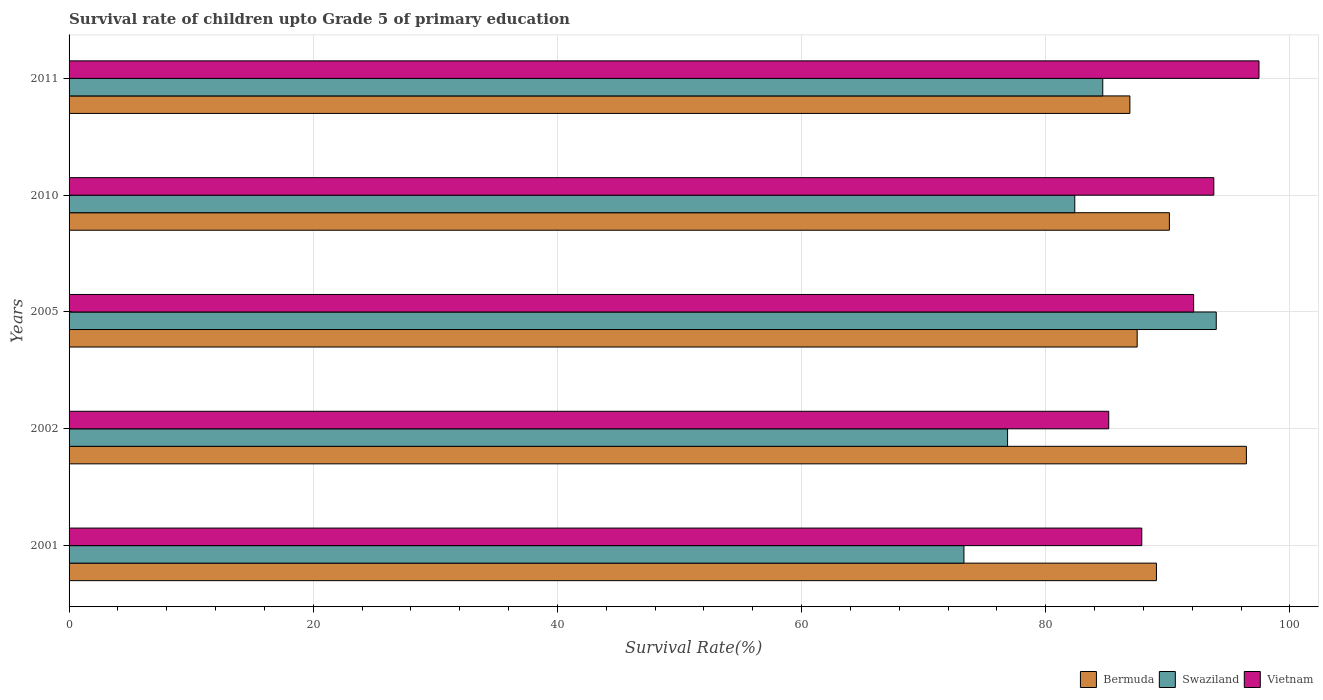How many different coloured bars are there?
Offer a very short reply. 3. How many groups of bars are there?
Your response must be concise. 5. Are the number of bars per tick equal to the number of legend labels?
Give a very brief answer. Yes. How many bars are there on the 5th tick from the bottom?
Your answer should be very brief. 3. What is the survival rate of children in Vietnam in 2001?
Your response must be concise. 87.87. Across all years, what is the maximum survival rate of children in Vietnam?
Ensure brevity in your answer.  97.47. Across all years, what is the minimum survival rate of children in Swaziland?
Your answer should be compact. 73.3. What is the total survival rate of children in Vietnam in the graph?
Keep it short and to the point. 456.41. What is the difference between the survival rate of children in Swaziland in 2005 and that in 2010?
Offer a very short reply. 11.59. What is the difference between the survival rate of children in Swaziland in 2011 and the survival rate of children in Bermuda in 2001?
Provide a short and direct response. -4.4. What is the average survival rate of children in Swaziland per year?
Offer a terse response. 82.24. In the year 2011, what is the difference between the survival rate of children in Bermuda and survival rate of children in Vietnam?
Your answer should be compact. -10.58. In how many years, is the survival rate of children in Bermuda greater than 52 %?
Your answer should be very brief. 5. What is the ratio of the survival rate of children in Bermuda in 2002 to that in 2011?
Offer a terse response. 1.11. Is the survival rate of children in Vietnam in 2001 less than that in 2011?
Your answer should be compact. Yes. Is the difference between the survival rate of children in Bermuda in 2002 and 2005 greater than the difference between the survival rate of children in Vietnam in 2002 and 2005?
Your answer should be compact. Yes. What is the difference between the highest and the second highest survival rate of children in Vietnam?
Provide a succinct answer. 3.7. What is the difference between the highest and the lowest survival rate of children in Swaziland?
Your answer should be compact. 20.67. What does the 3rd bar from the top in 2002 represents?
Your response must be concise. Bermuda. What does the 2nd bar from the bottom in 2005 represents?
Ensure brevity in your answer.  Swaziland. Is it the case that in every year, the sum of the survival rate of children in Vietnam and survival rate of children in Bermuda is greater than the survival rate of children in Swaziland?
Offer a very short reply. Yes. How many bars are there?
Make the answer very short. 15. How many years are there in the graph?
Your response must be concise. 5. What is the difference between two consecutive major ticks on the X-axis?
Give a very brief answer. 20. Are the values on the major ticks of X-axis written in scientific E-notation?
Your answer should be compact. No. What is the title of the graph?
Ensure brevity in your answer.  Survival rate of children upto Grade 5 of primary education. Does "Belarus" appear as one of the legend labels in the graph?
Offer a very short reply. No. What is the label or title of the X-axis?
Offer a terse response. Survival Rate(%). What is the Survival Rate(%) of Bermuda in 2001?
Offer a terse response. 89.07. What is the Survival Rate(%) of Swaziland in 2001?
Offer a terse response. 73.3. What is the Survival Rate(%) in Vietnam in 2001?
Offer a terse response. 87.87. What is the Survival Rate(%) of Bermuda in 2002?
Your answer should be compact. 96.44. What is the Survival Rate(%) in Swaziland in 2002?
Provide a succinct answer. 76.88. What is the Survival Rate(%) of Vietnam in 2002?
Your response must be concise. 85.17. What is the Survival Rate(%) of Bermuda in 2005?
Offer a very short reply. 87.5. What is the Survival Rate(%) of Swaziland in 2005?
Keep it short and to the point. 93.97. What is the Survival Rate(%) of Vietnam in 2005?
Provide a short and direct response. 92.12. What is the Survival Rate(%) in Bermuda in 2010?
Ensure brevity in your answer.  90.13. What is the Survival Rate(%) in Swaziland in 2010?
Offer a very short reply. 82.38. What is the Survival Rate(%) of Vietnam in 2010?
Your answer should be very brief. 93.78. What is the Survival Rate(%) in Bermuda in 2011?
Provide a short and direct response. 86.9. What is the Survival Rate(%) in Swaziland in 2011?
Make the answer very short. 84.68. What is the Survival Rate(%) of Vietnam in 2011?
Your response must be concise. 97.47. Across all years, what is the maximum Survival Rate(%) in Bermuda?
Keep it short and to the point. 96.44. Across all years, what is the maximum Survival Rate(%) in Swaziland?
Offer a very short reply. 93.97. Across all years, what is the maximum Survival Rate(%) of Vietnam?
Offer a terse response. 97.47. Across all years, what is the minimum Survival Rate(%) of Bermuda?
Offer a very short reply. 86.9. Across all years, what is the minimum Survival Rate(%) of Swaziland?
Keep it short and to the point. 73.3. Across all years, what is the minimum Survival Rate(%) of Vietnam?
Provide a short and direct response. 85.17. What is the total Survival Rate(%) in Bermuda in the graph?
Your response must be concise. 450.05. What is the total Survival Rate(%) of Swaziland in the graph?
Your response must be concise. 411.22. What is the total Survival Rate(%) of Vietnam in the graph?
Your answer should be compact. 456.41. What is the difference between the Survival Rate(%) of Bermuda in 2001 and that in 2002?
Offer a terse response. -7.37. What is the difference between the Survival Rate(%) in Swaziland in 2001 and that in 2002?
Offer a very short reply. -3.57. What is the difference between the Survival Rate(%) in Vietnam in 2001 and that in 2002?
Offer a very short reply. 2.71. What is the difference between the Survival Rate(%) of Bermuda in 2001 and that in 2005?
Offer a very short reply. 1.58. What is the difference between the Survival Rate(%) in Swaziland in 2001 and that in 2005?
Your answer should be compact. -20.67. What is the difference between the Survival Rate(%) of Vietnam in 2001 and that in 2005?
Provide a succinct answer. -4.25. What is the difference between the Survival Rate(%) in Bermuda in 2001 and that in 2010?
Your answer should be very brief. -1.06. What is the difference between the Survival Rate(%) of Swaziland in 2001 and that in 2010?
Offer a terse response. -9.08. What is the difference between the Survival Rate(%) in Vietnam in 2001 and that in 2010?
Offer a very short reply. -5.9. What is the difference between the Survival Rate(%) of Bermuda in 2001 and that in 2011?
Your answer should be compact. 2.18. What is the difference between the Survival Rate(%) in Swaziland in 2001 and that in 2011?
Your answer should be very brief. -11.37. What is the difference between the Survival Rate(%) of Vietnam in 2001 and that in 2011?
Ensure brevity in your answer.  -9.6. What is the difference between the Survival Rate(%) of Bermuda in 2002 and that in 2005?
Your response must be concise. 8.95. What is the difference between the Survival Rate(%) in Swaziland in 2002 and that in 2005?
Make the answer very short. -17.09. What is the difference between the Survival Rate(%) in Vietnam in 2002 and that in 2005?
Provide a succinct answer. -6.96. What is the difference between the Survival Rate(%) in Bermuda in 2002 and that in 2010?
Ensure brevity in your answer.  6.31. What is the difference between the Survival Rate(%) in Swaziland in 2002 and that in 2010?
Keep it short and to the point. -5.51. What is the difference between the Survival Rate(%) in Vietnam in 2002 and that in 2010?
Offer a very short reply. -8.61. What is the difference between the Survival Rate(%) of Bermuda in 2002 and that in 2011?
Keep it short and to the point. 9.54. What is the difference between the Survival Rate(%) of Swaziland in 2002 and that in 2011?
Your answer should be compact. -7.8. What is the difference between the Survival Rate(%) in Vietnam in 2002 and that in 2011?
Provide a succinct answer. -12.31. What is the difference between the Survival Rate(%) of Bermuda in 2005 and that in 2010?
Ensure brevity in your answer.  -2.64. What is the difference between the Survival Rate(%) of Swaziland in 2005 and that in 2010?
Provide a succinct answer. 11.59. What is the difference between the Survival Rate(%) of Vietnam in 2005 and that in 2010?
Your answer should be compact. -1.65. What is the difference between the Survival Rate(%) of Bermuda in 2005 and that in 2011?
Your response must be concise. 0.6. What is the difference between the Survival Rate(%) in Swaziland in 2005 and that in 2011?
Give a very brief answer. 9.3. What is the difference between the Survival Rate(%) in Vietnam in 2005 and that in 2011?
Offer a very short reply. -5.35. What is the difference between the Survival Rate(%) of Bermuda in 2010 and that in 2011?
Your answer should be very brief. 3.24. What is the difference between the Survival Rate(%) of Swaziland in 2010 and that in 2011?
Offer a very short reply. -2.29. What is the difference between the Survival Rate(%) in Vietnam in 2010 and that in 2011?
Keep it short and to the point. -3.7. What is the difference between the Survival Rate(%) of Bermuda in 2001 and the Survival Rate(%) of Swaziland in 2002?
Offer a very short reply. 12.2. What is the difference between the Survival Rate(%) of Bermuda in 2001 and the Survival Rate(%) of Vietnam in 2002?
Offer a very short reply. 3.91. What is the difference between the Survival Rate(%) of Swaziland in 2001 and the Survival Rate(%) of Vietnam in 2002?
Keep it short and to the point. -11.86. What is the difference between the Survival Rate(%) of Bermuda in 2001 and the Survival Rate(%) of Swaziland in 2005?
Make the answer very short. -4.9. What is the difference between the Survival Rate(%) in Bermuda in 2001 and the Survival Rate(%) in Vietnam in 2005?
Make the answer very short. -3.05. What is the difference between the Survival Rate(%) of Swaziland in 2001 and the Survival Rate(%) of Vietnam in 2005?
Provide a succinct answer. -18.82. What is the difference between the Survival Rate(%) of Bermuda in 2001 and the Survival Rate(%) of Swaziland in 2010?
Make the answer very short. 6.69. What is the difference between the Survival Rate(%) of Bermuda in 2001 and the Survival Rate(%) of Vietnam in 2010?
Give a very brief answer. -4.7. What is the difference between the Survival Rate(%) in Swaziland in 2001 and the Survival Rate(%) in Vietnam in 2010?
Make the answer very short. -20.47. What is the difference between the Survival Rate(%) of Bermuda in 2001 and the Survival Rate(%) of Swaziland in 2011?
Ensure brevity in your answer.  4.4. What is the difference between the Survival Rate(%) of Bermuda in 2001 and the Survival Rate(%) of Vietnam in 2011?
Offer a very short reply. -8.4. What is the difference between the Survival Rate(%) of Swaziland in 2001 and the Survival Rate(%) of Vietnam in 2011?
Make the answer very short. -24.17. What is the difference between the Survival Rate(%) in Bermuda in 2002 and the Survival Rate(%) in Swaziland in 2005?
Your response must be concise. 2.47. What is the difference between the Survival Rate(%) in Bermuda in 2002 and the Survival Rate(%) in Vietnam in 2005?
Your answer should be very brief. 4.32. What is the difference between the Survival Rate(%) of Swaziland in 2002 and the Survival Rate(%) of Vietnam in 2005?
Offer a very short reply. -15.24. What is the difference between the Survival Rate(%) of Bermuda in 2002 and the Survival Rate(%) of Swaziland in 2010?
Give a very brief answer. 14.06. What is the difference between the Survival Rate(%) of Bermuda in 2002 and the Survival Rate(%) of Vietnam in 2010?
Provide a short and direct response. 2.67. What is the difference between the Survival Rate(%) of Swaziland in 2002 and the Survival Rate(%) of Vietnam in 2010?
Provide a short and direct response. -16.9. What is the difference between the Survival Rate(%) in Bermuda in 2002 and the Survival Rate(%) in Swaziland in 2011?
Give a very brief answer. 11.77. What is the difference between the Survival Rate(%) in Bermuda in 2002 and the Survival Rate(%) in Vietnam in 2011?
Keep it short and to the point. -1.03. What is the difference between the Survival Rate(%) in Swaziland in 2002 and the Survival Rate(%) in Vietnam in 2011?
Offer a terse response. -20.6. What is the difference between the Survival Rate(%) in Bermuda in 2005 and the Survival Rate(%) in Swaziland in 2010?
Keep it short and to the point. 5.11. What is the difference between the Survival Rate(%) in Bermuda in 2005 and the Survival Rate(%) in Vietnam in 2010?
Offer a terse response. -6.28. What is the difference between the Survival Rate(%) of Swaziland in 2005 and the Survival Rate(%) of Vietnam in 2010?
Make the answer very short. 0.2. What is the difference between the Survival Rate(%) of Bermuda in 2005 and the Survival Rate(%) of Swaziland in 2011?
Your answer should be compact. 2.82. What is the difference between the Survival Rate(%) in Bermuda in 2005 and the Survival Rate(%) in Vietnam in 2011?
Provide a succinct answer. -9.98. What is the difference between the Survival Rate(%) of Swaziland in 2005 and the Survival Rate(%) of Vietnam in 2011?
Provide a succinct answer. -3.5. What is the difference between the Survival Rate(%) in Bermuda in 2010 and the Survival Rate(%) in Swaziland in 2011?
Offer a terse response. 5.46. What is the difference between the Survival Rate(%) in Bermuda in 2010 and the Survival Rate(%) in Vietnam in 2011?
Your answer should be compact. -7.34. What is the difference between the Survival Rate(%) in Swaziland in 2010 and the Survival Rate(%) in Vietnam in 2011?
Offer a terse response. -15.09. What is the average Survival Rate(%) of Bermuda per year?
Offer a very short reply. 90.01. What is the average Survival Rate(%) in Swaziland per year?
Give a very brief answer. 82.24. What is the average Survival Rate(%) of Vietnam per year?
Your answer should be very brief. 91.28. In the year 2001, what is the difference between the Survival Rate(%) of Bermuda and Survival Rate(%) of Swaziland?
Offer a terse response. 15.77. In the year 2001, what is the difference between the Survival Rate(%) in Bermuda and Survival Rate(%) in Vietnam?
Offer a terse response. 1.2. In the year 2001, what is the difference between the Survival Rate(%) in Swaziland and Survival Rate(%) in Vietnam?
Ensure brevity in your answer.  -14.57. In the year 2002, what is the difference between the Survival Rate(%) of Bermuda and Survival Rate(%) of Swaziland?
Offer a terse response. 19.56. In the year 2002, what is the difference between the Survival Rate(%) of Bermuda and Survival Rate(%) of Vietnam?
Offer a very short reply. 11.28. In the year 2002, what is the difference between the Survival Rate(%) of Swaziland and Survival Rate(%) of Vietnam?
Your response must be concise. -8.29. In the year 2005, what is the difference between the Survival Rate(%) in Bermuda and Survival Rate(%) in Swaziland?
Offer a terse response. -6.48. In the year 2005, what is the difference between the Survival Rate(%) in Bermuda and Survival Rate(%) in Vietnam?
Your response must be concise. -4.63. In the year 2005, what is the difference between the Survival Rate(%) of Swaziland and Survival Rate(%) of Vietnam?
Keep it short and to the point. 1.85. In the year 2010, what is the difference between the Survival Rate(%) of Bermuda and Survival Rate(%) of Swaziland?
Keep it short and to the point. 7.75. In the year 2010, what is the difference between the Survival Rate(%) of Bermuda and Survival Rate(%) of Vietnam?
Your answer should be compact. -3.64. In the year 2010, what is the difference between the Survival Rate(%) in Swaziland and Survival Rate(%) in Vietnam?
Your answer should be compact. -11.39. In the year 2011, what is the difference between the Survival Rate(%) in Bermuda and Survival Rate(%) in Swaziland?
Your answer should be very brief. 2.22. In the year 2011, what is the difference between the Survival Rate(%) in Bermuda and Survival Rate(%) in Vietnam?
Your answer should be compact. -10.58. In the year 2011, what is the difference between the Survival Rate(%) in Swaziland and Survival Rate(%) in Vietnam?
Ensure brevity in your answer.  -12.8. What is the ratio of the Survival Rate(%) of Bermuda in 2001 to that in 2002?
Keep it short and to the point. 0.92. What is the ratio of the Survival Rate(%) in Swaziland in 2001 to that in 2002?
Give a very brief answer. 0.95. What is the ratio of the Survival Rate(%) in Vietnam in 2001 to that in 2002?
Your answer should be very brief. 1.03. What is the ratio of the Survival Rate(%) of Bermuda in 2001 to that in 2005?
Provide a short and direct response. 1.02. What is the ratio of the Survival Rate(%) of Swaziland in 2001 to that in 2005?
Your answer should be compact. 0.78. What is the ratio of the Survival Rate(%) of Vietnam in 2001 to that in 2005?
Provide a succinct answer. 0.95. What is the ratio of the Survival Rate(%) in Bermuda in 2001 to that in 2010?
Provide a succinct answer. 0.99. What is the ratio of the Survival Rate(%) in Swaziland in 2001 to that in 2010?
Provide a succinct answer. 0.89. What is the ratio of the Survival Rate(%) in Vietnam in 2001 to that in 2010?
Make the answer very short. 0.94. What is the ratio of the Survival Rate(%) in Swaziland in 2001 to that in 2011?
Ensure brevity in your answer.  0.87. What is the ratio of the Survival Rate(%) of Vietnam in 2001 to that in 2011?
Your response must be concise. 0.9. What is the ratio of the Survival Rate(%) of Bermuda in 2002 to that in 2005?
Offer a terse response. 1.1. What is the ratio of the Survival Rate(%) in Swaziland in 2002 to that in 2005?
Offer a terse response. 0.82. What is the ratio of the Survival Rate(%) of Vietnam in 2002 to that in 2005?
Offer a very short reply. 0.92. What is the ratio of the Survival Rate(%) in Bermuda in 2002 to that in 2010?
Your response must be concise. 1.07. What is the ratio of the Survival Rate(%) in Swaziland in 2002 to that in 2010?
Provide a succinct answer. 0.93. What is the ratio of the Survival Rate(%) of Vietnam in 2002 to that in 2010?
Give a very brief answer. 0.91. What is the ratio of the Survival Rate(%) of Bermuda in 2002 to that in 2011?
Your answer should be very brief. 1.11. What is the ratio of the Survival Rate(%) in Swaziland in 2002 to that in 2011?
Keep it short and to the point. 0.91. What is the ratio of the Survival Rate(%) in Vietnam in 2002 to that in 2011?
Give a very brief answer. 0.87. What is the ratio of the Survival Rate(%) in Bermuda in 2005 to that in 2010?
Offer a very short reply. 0.97. What is the ratio of the Survival Rate(%) in Swaziland in 2005 to that in 2010?
Your answer should be very brief. 1.14. What is the ratio of the Survival Rate(%) in Vietnam in 2005 to that in 2010?
Offer a very short reply. 0.98. What is the ratio of the Survival Rate(%) of Bermuda in 2005 to that in 2011?
Offer a terse response. 1.01. What is the ratio of the Survival Rate(%) of Swaziland in 2005 to that in 2011?
Offer a terse response. 1.11. What is the ratio of the Survival Rate(%) in Vietnam in 2005 to that in 2011?
Provide a succinct answer. 0.95. What is the ratio of the Survival Rate(%) of Bermuda in 2010 to that in 2011?
Offer a terse response. 1.04. What is the ratio of the Survival Rate(%) of Swaziland in 2010 to that in 2011?
Make the answer very short. 0.97. What is the difference between the highest and the second highest Survival Rate(%) of Bermuda?
Your answer should be very brief. 6.31. What is the difference between the highest and the second highest Survival Rate(%) in Swaziland?
Offer a terse response. 9.3. What is the difference between the highest and the second highest Survival Rate(%) in Vietnam?
Your answer should be compact. 3.7. What is the difference between the highest and the lowest Survival Rate(%) of Bermuda?
Your response must be concise. 9.54. What is the difference between the highest and the lowest Survival Rate(%) of Swaziland?
Your answer should be compact. 20.67. What is the difference between the highest and the lowest Survival Rate(%) of Vietnam?
Give a very brief answer. 12.31. 